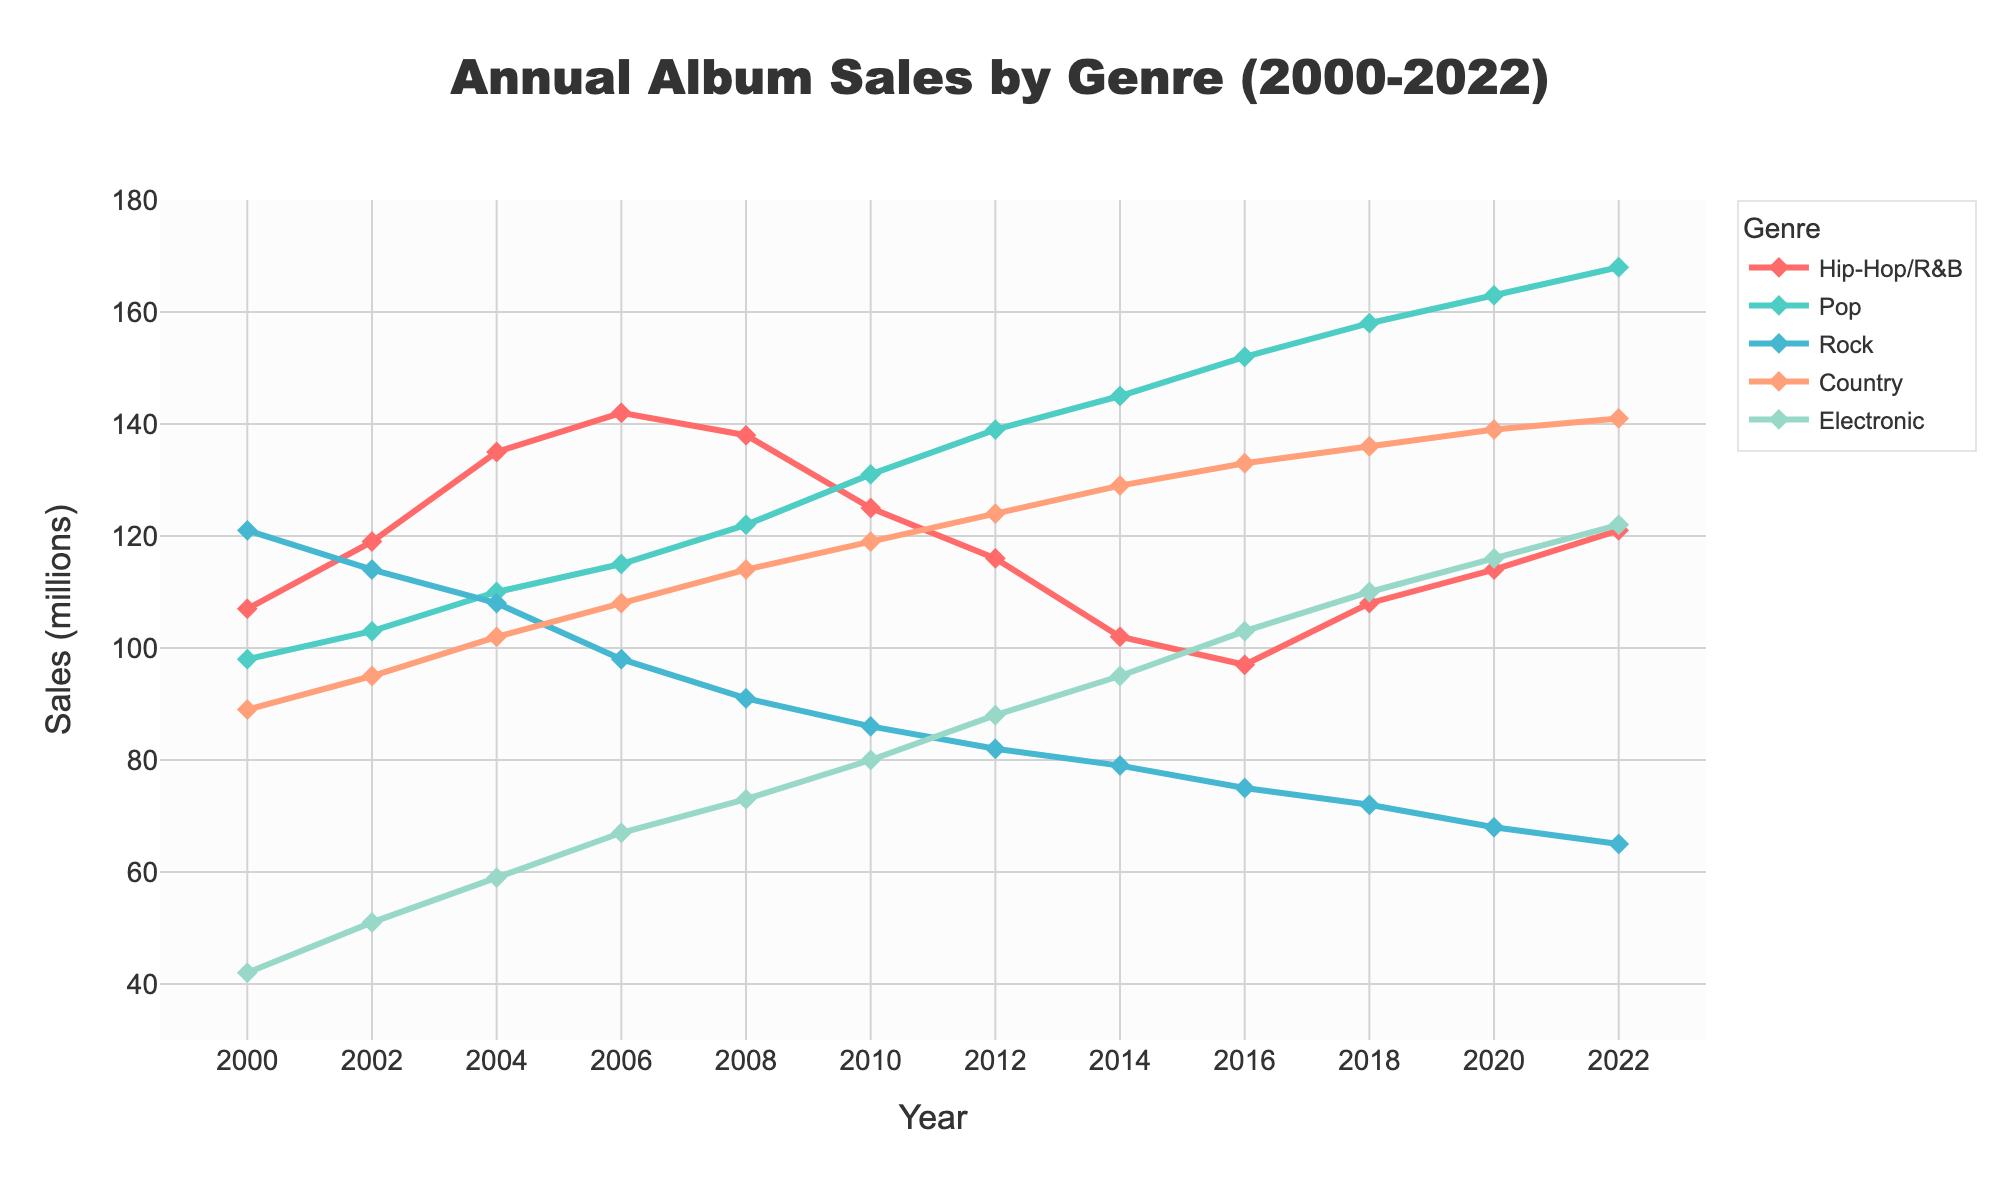What genre had the highest annual sales in 2022? Observe the data points for 2022. Pop had the highest sales in 2022 with 168 million albums sold.
Answer: Pop Over the entire period, how did Hip-Hop/R&B sales trend compared to Pop sales? Hip-Hop/R&B sales peaked around 2006 and then generally declined, while Pop sales consistently increased over time.
Answer: Hip-Hop/R&B declined, Pop increased Which two genres had the closest sales figures in 2008 and what were their sales? Compare the sales data for 2008. Hip-Hop/R&B had 138 million and Rock had 91 million, which are relatively close compared to other genres.
Answer: Hip-Hop/R&B: 138 million, Rock: 91 million From 2000 to 2022, which genre experienced the largest overall increase in sales? Calculate the difference in sales between 2000 and 2022 for each genre. Pop went from 98 million to 168 million, which is the largest increase of 70 million.
Answer: Pop (70 million) What is the average annual sales of Country music over the period from 2000 to 2022? Sum annual sales of Country across all years and divide by the number of years (12). The sum is (89+95+102+108+114+119+124+129+133+136+139+141) = 1429. The average is 1429 / 12 = 119.08.
Answer: 119.08 million In which year did Electronic music see its highest sales, and what was the sales figure? Look at the annual sales data for Electronic music over all years. The highest sales were in 2022 with 122 million.
Answer: 2022, 122 million What are the sales differences between Hip-Hop/R&B and Electronic in 2004 and 2018? Subtract Electronic sales from Hip-Hop/R&B sales for both years. In 2004: 135-59 = 76 million, and in 2018: 108-110 = -2 million.
Answer: 2004: 76 million, 2018: -2 million 